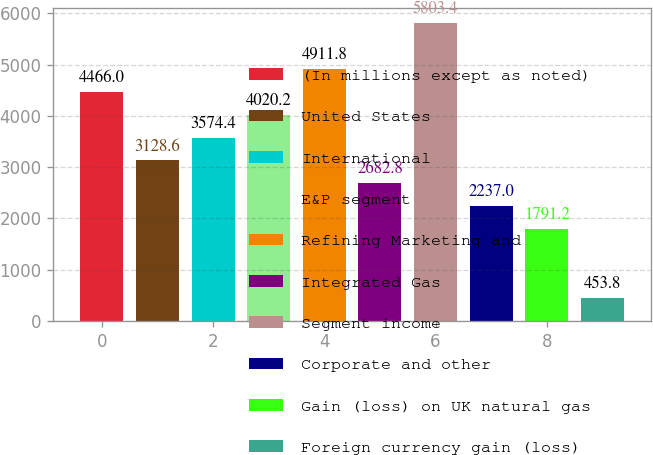Convert chart. <chart><loc_0><loc_0><loc_500><loc_500><bar_chart><fcel>(In millions except as noted)<fcel>United States<fcel>International<fcel>E&P segment<fcel>Refining Marketing and<fcel>Integrated Gas<fcel>Segment income<fcel>Corporate and other<fcel>Gain (loss) on UK natural gas<fcel>Foreign currency gain (loss)<nl><fcel>4466<fcel>3128.6<fcel>3574.4<fcel>4020.2<fcel>4911.8<fcel>2682.8<fcel>5803.4<fcel>2237<fcel>1791.2<fcel>453.8<nl></chart> 